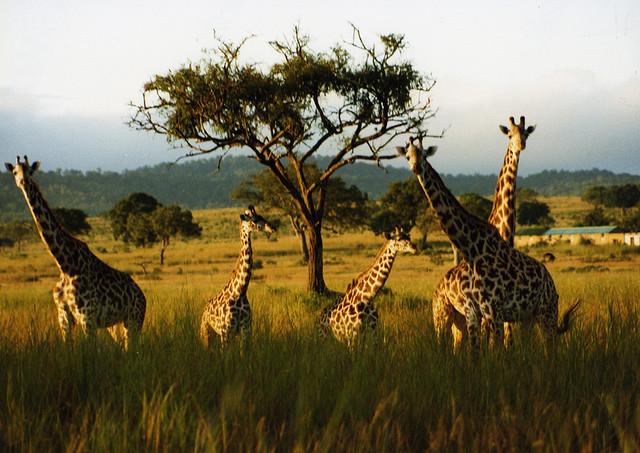How many giraffes are in the image?
Write a very short answer. 5. Hazy or sunny?
Quick response, please. Sunny. Was this taken in Europe?
Write a very short answer. No. 